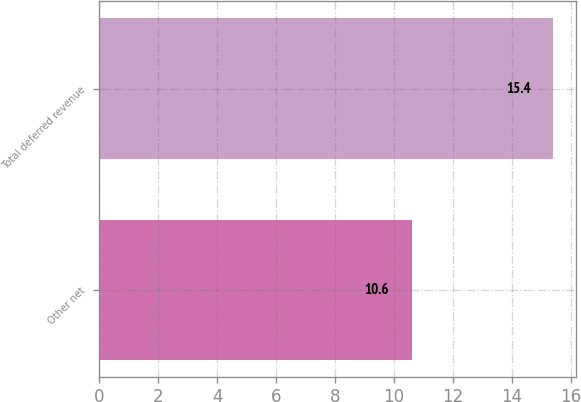Convert chart. <chart><loc_0><loc_0><loc_500><loc_500><bar_chart><fcel>Other net<fcel>Total deferred revenue<nl><fcel>10.6<fcel>15.4<nl></chart> 